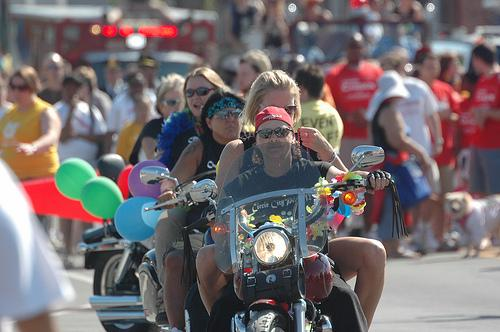Examine the image for an oddly sized or shaped part of a motorcycle. There is a part of a wheel that seems to be cut off and only measures 9 pixels in width and height. Analyze the sentiment or mood conveyed by the image. The image conveys a positive and festive mood due to the colorful balloons, decorated motorcycles, and people participating in the parade. What is the main event happening in the image? A motorcycle parade with several women riding motorcycles and carrying colorful balloons. Identify the animals present in the image. A dog wearing a chest harness and a neckerchief is watching the motorcycles. Count the number of women riding motorcycles in the image. There appears to be a group of women, which could be at least four or more, riding motorcycles. What are some notable accessories or items on the motorcycles? Colorful ribbons on motors, glowing headlight, two green balloons, blue and purple balloons, and flowers hanging from handlebars. Describe the street on which the parade is taking place. The parade is taking place on a grey paved street that stretches across the full width of the image. Provide a brief description of the woman at the front of the motorcycle parade. The woman is wearing sunglasses, a red cap, and a short-sleeved black tee shirt while leading the motorcycle parade. What is a unique feature of the motorcycle ridden by the woman wearing the red cap? The motorcycle has a large glass wind block in front of the rider. How many different colors of balloons are visible in the image? There are at least three colors of balloons: green, blue, and purple. What is the condition of the street in the image? Grey and paved What is the color of the shirt of the large woman in the image? Yellow What is the dominant color of the balloons on the bike? Green, blue, and purple Do you notice any bikers wearing long-sleeved shirts? There is only mention of short-sleeved shirts and no long-sleeved shirts in the image. What is the color of the ribbon in the image? Colorful What are the women wearing at the front of the motorcycle parade? Sunglasses Is there a cat in a chest harness? There is only mention of a dog in a chest harness, no cat in the image. List the objects mentioned that are related to the motorcycles. Colorful ribbons, glowing headlight, sideview mirror, wheel, guard, handle, large glass wind block Can you spot a polka-dotted balloon in the image? There are only green, blue, and purple balloons mentioned, but no polka-dotted balloons. What is the color of the bandana the woman riding the motorcycle is wearing? Blue What is hanging from the handlebars of one of the motorcycles? Flowers Describe the appearance of the closest rider in the motorcycle parade. The closest rider is wearing a red bandana. What is the position of the dog in relation to the motorcycles? Dog on the right Do you see a blue ribbon on the motor? There are only colorful ribbons mentioned, and none is specifically blue. What does the dog in the image wear around its neck? Neckerchief Can you find a pink motorcycle in the parade? There is no mention of any specific motorcycle color, thus no mention of a pink motorcycle. What kind of event is taking place? A motorcycle parade Describe the scene with the women and motorcycles. A group of women is riding motorcycles in a parade with colorful balloons, wearing sunglasses, caps, and short-sleeved shirts. A dog with a chest harness watches on. Identify the activity of the people in the image. Riding motorcycles in a parade Can you find the woman with the orange cap? There is only mention of a red cap on a biker, no orange cap mentioned. Among the options below, what are the women wearing at the front of the motorcycle parade? b) yellow shirt Provide a short description of the dog in the picture. A dog in a chest harness with a neckerchief is watching the motorcycles. What type of shirt is the woman wearing while riding the motorcycle? Short-sleeved black tee shirt What is the main color of the cap on the biker? Red 